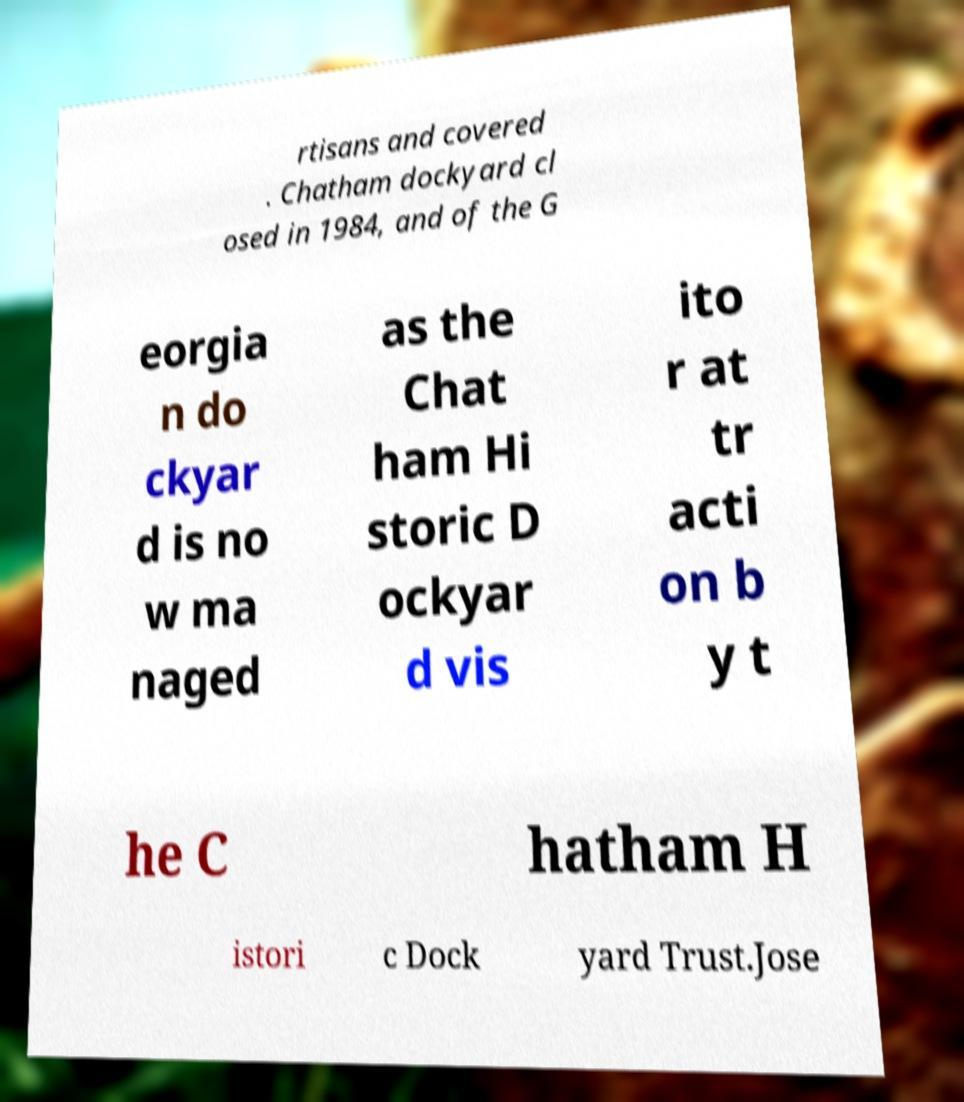Please read and relay the text visible in this image. What does it say? rtisans and covered . Chatham dockyard cl osed in 1984, and of the G eorgia n do ckyar d is no w ma naged as the Chat ham Hi storic D ockyar d vis ito r at tr acti on b y t he C hatham H istori c Dock yard Trust.Jose 